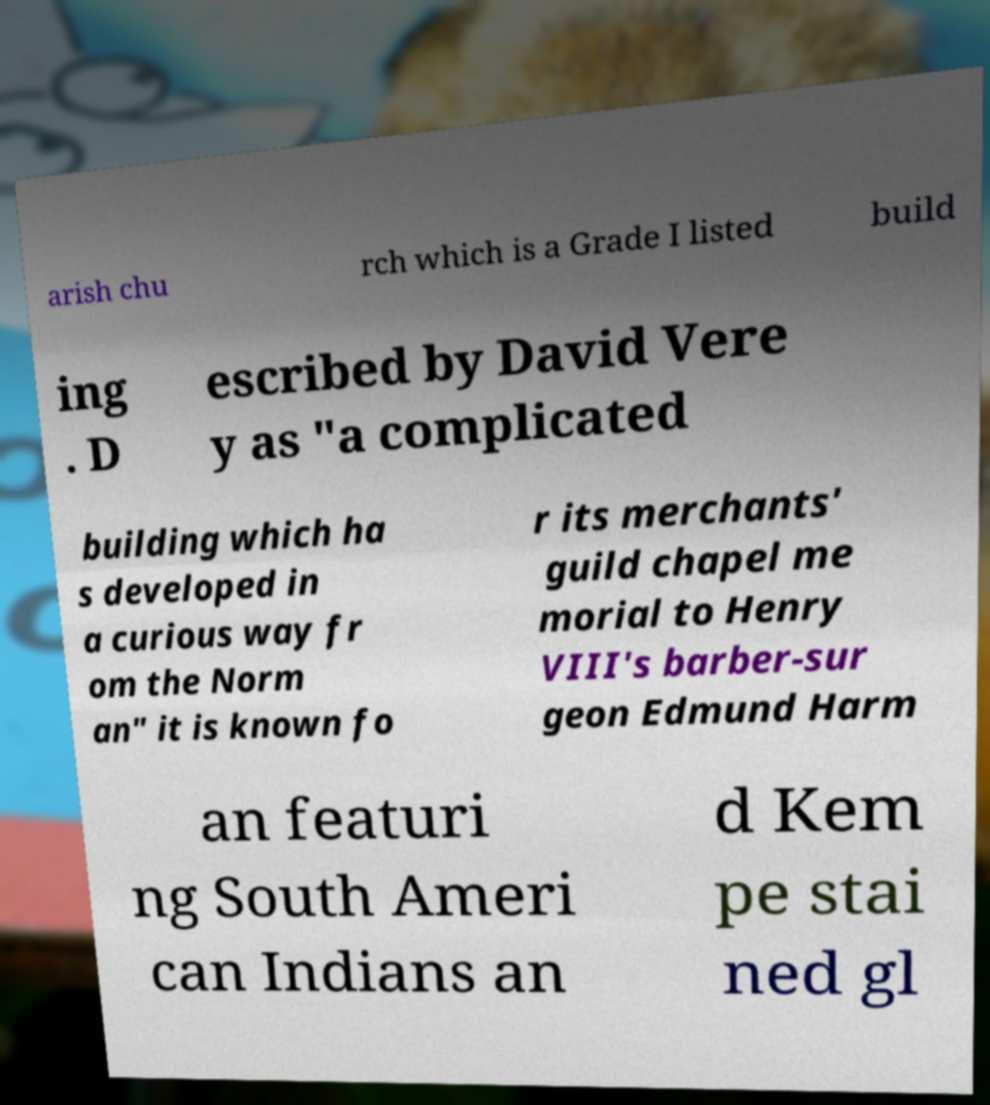Please identify and transcribe the text found in this image. arish chu rch which is a Grade I listed build ing . D escribed by David Vere y as "a complicated building which ha s developed in a curious way fr om the Norm an" it is known fo r its merchants' guild chapel me morial to Henry VIII's barber-sur geon Edmund Harm an featuri ng South Ameri can Indians an d Kem pe stai ned gl 